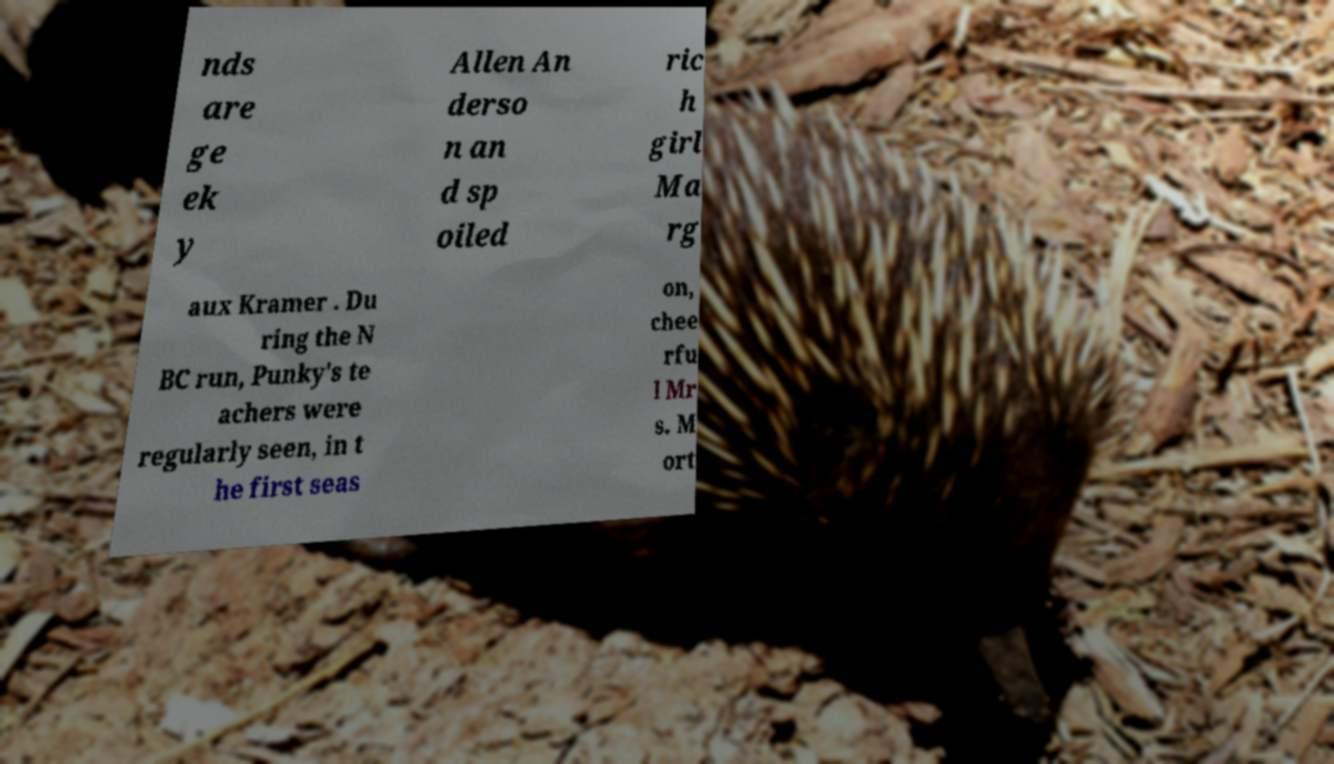Please read and relay the text visible in this image. What does it say? nds are ge ek y Allen An derso n an d sp oiled ric h girl Ma rg aux Kramer . Du ring the N BC run, Punky's te achers were regularly seen, in t he first seas on, chee rfu l Mr s. M ort 